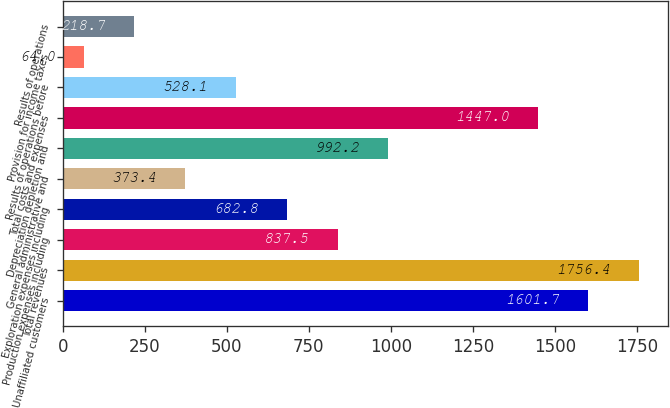<chart> <loc_0><loc_0><loc_500><loc_500><bar_chart><fcel>Unaffiliated customers<fcel>Total revenues<fcel>Production expenses including<fcel>Exploration expenses including<fcel>General administrative and<fcel>Depreciation depletion and<fcel>Total costs and expenses<fcel>Results of operations before<fcel>Provision for income taxes<fcel>Results of operations<nl><fcel>1601.7<fcel>1756.4<fcel>837.5<fcel>682.8<fcel>373.4<fcel>992.2<fcel>1447<fcel>528.1<fcel>64<fcel>218.7<nl></chart> 